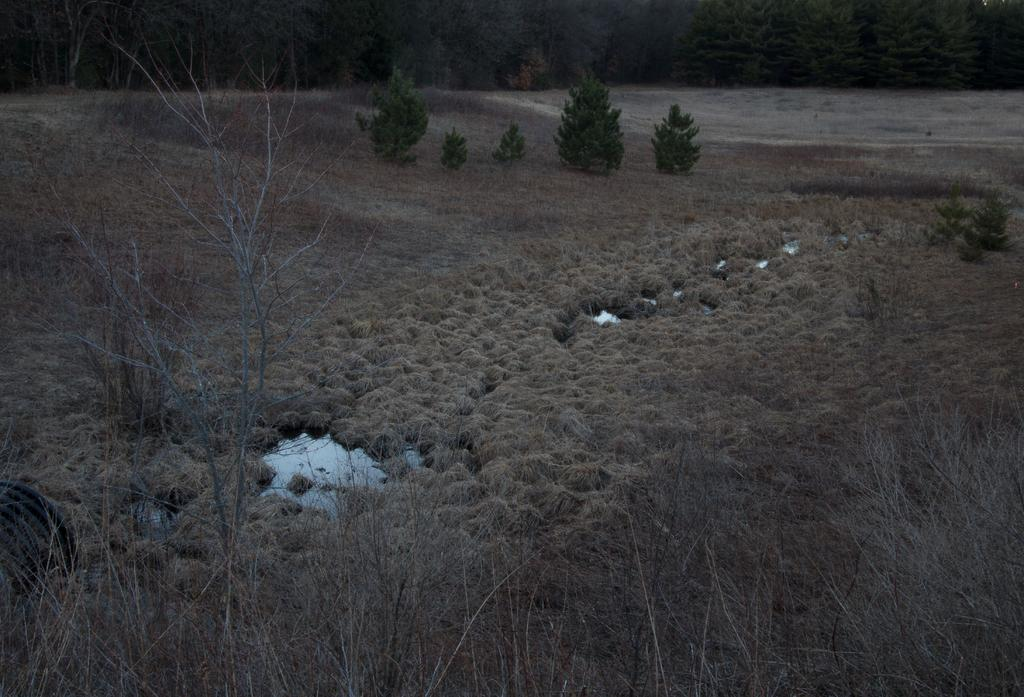What type of plants are in the image? There are dry plants in the image. What else can be seen in the image besides the dry plants? There is water visible in the image. What is the condition of the grass in the image? Dry grass is present in the image. What can be seen in the background of the image? Plants and trees are visible in the background of the image. What type of skin condition can be seen on the plants in the image? There is no skin condition present on the plants in the image, as plants do not have skin. 